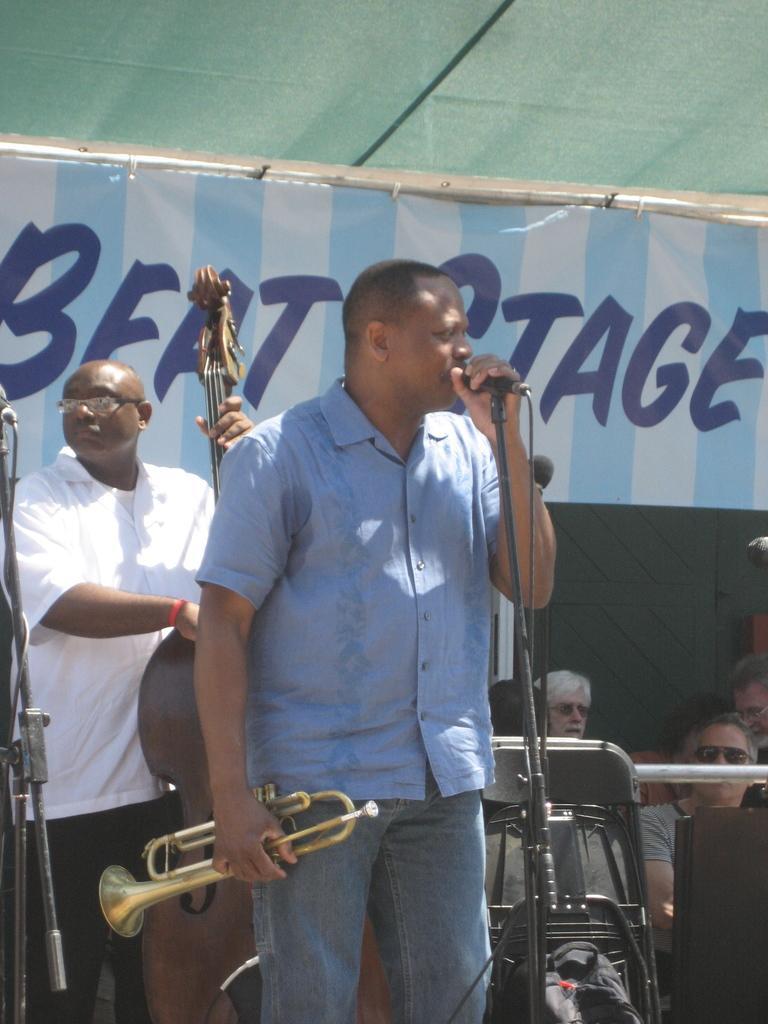In one or two sentences, can you explain what this image depicts? In the picture I can people among them some are sitting and some are standing. I can also see the people in front of the image are holding musical instruments in hands. I can also see microphones and some other objects. In the background I can see something written on the banner. 